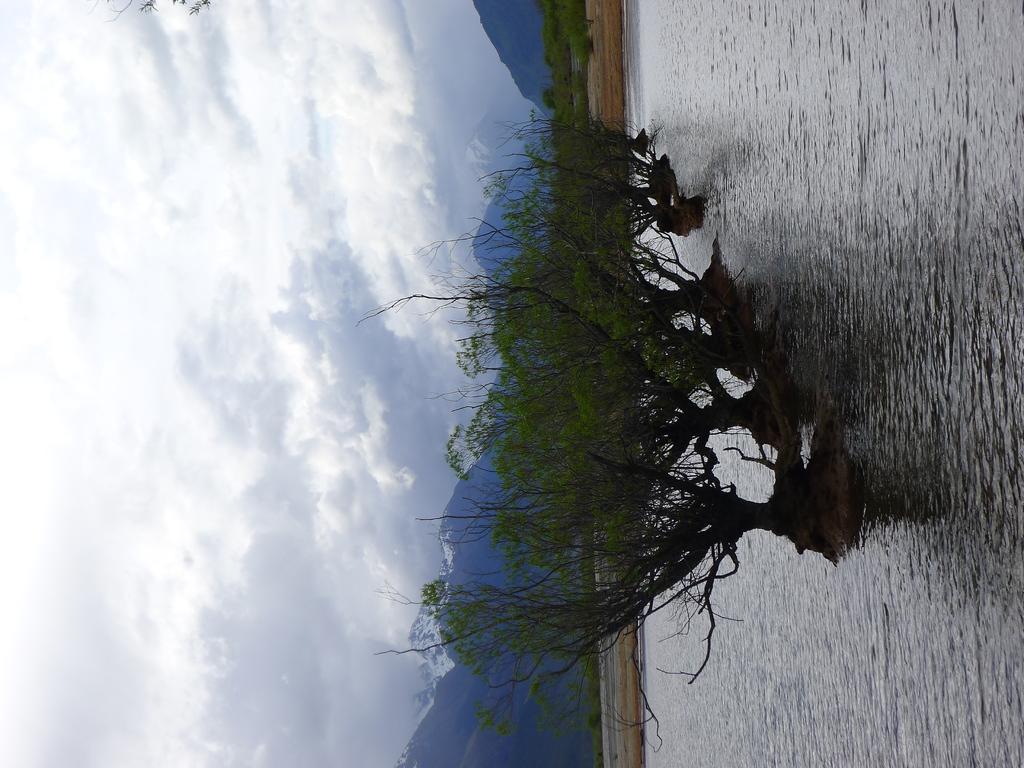Please provide a concise description of this image. In this image I can see trees on the water. There are mountains at the back. There are clouds in the sky. 